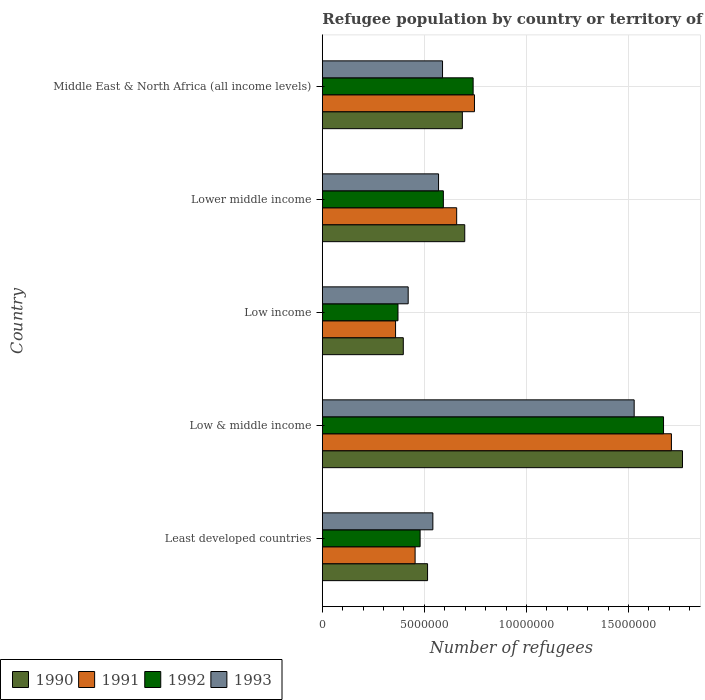How many different coloured bars are there?
Give a very brief answer. 4. Are the number of bars per tick equal to the number of legend labels?
Offer a terse response. Yes. How many bars are there on the 4th tick from the top?
Make the answer very short. 4. How many bars are there on the 3rd tick from the bottom?
Your response must be concise. 4. What is the label of the 1st group of bars from the top?
Give a very brief answer. Middle East & North Africa (all income levels). In how many cases, is the number of bars for a given country not equal to the number of legend labels?
Provide a short and direct response. 0. What is the number of refugees in 1992 in Low & middle income?
Keep it short and to the point. 1.67e+07. Across all countries, what is the maximum number of refugees in 1991?
Ensure brevity in your answer.  1.71e+07. Across all countries, what is the minimum number of refugees in 1993?
Make the answer very short. 4.21e+06. In which country was the number of refugees in 1993 minimum?
Your response must be concise. Low income. What is the total number of refugees in 1991 in the graph?
Your response must be concise. 3.93e+07. What is the difference between the number of refugees in 1990 in Least developed countries and that in Lower middle income?
Give a very brief answer. -1.82e+06. What is the difference between the number of refugees in 1990 in Middle East & North Africa (all income levels) and the number of refugees in 1992 in Low income?
Ensure brevity in your answer.  3.15e+06. What is the average number of refugees in 1993 per country?
Give a very brief answer. 7.30e+06. What is the difference between the number of refugees in 1993 and number of refugees in 1990 in Low & middle income?
Keep it short and to the point. -2.37e+06. In how many countries, is the number of refugees in 1992 greater than 14000000 ?
Your answer should be very brief. 1. What is the ratio of the number of refugees in 1993 in Low & middle income to that in Middle East & North Africa (all income levels)?
Provide a succinct answer. 2.59. Is the number of refugees in 1992 in Low & middle income less than that in Lower middle income?
Provide a short and direct response. No. Is the difference between the number of refugees in 1993 in Least developed countries and Low & middle income greater than the difference between the number of refugees in 1990 in Least developed countries and Low & middle income?
Make the answer very short. Yes. What is the difference between the highest and the second highest number of refugees in 1993?
Offer a terse response. 9.39e+06. What is the difference between the highest and the lowest number of refugees in 1990?
Give a very brief answer. 1.37e+07. In how many countries, is the number of refugees in 1993 greater than the average number of refugees in 1993 taken over all countries?
Your answer should be compact. 1. Is the sum of the number of refugees in 1990 in Low income and Middle East & North Africa (all income levels) greater than the maximum number of refugees in 1993 across all countries?
Make the answer very short. No. Is it the case that in every country, the sum of the number of refugees in 1993 and number of refugees in 1992 is greater than the number of refugees in 1991?
Offer a terse response. Yes. How many countries are there in the graph?
Your answer should be very brief. 5. Does the graph contain grids?
Your answer should be very brief. Yes. Where does the legend appear in the graph?
Make the answer very short. Bottom left. How are the legend labels stacked?
Make the answer very short. Horizontal. What is the title of the graph?
Your answer should be compact. Refugee population by country or territory of asylum. Does "2001" appear as one of the legend labels in the graph?
Provide a short and direct response. No. What is the label or title of the X-axis?
Provide a short and direct response. Number of refugees. What is the label or title of the Y-axis?
Your answer should be compact. Country. What is the Number of refugees in 1990 in Least developed countries?
Offer a very short reply. 5.15e+06. What is the Number of refugees in 1991 in Least developed countries?
Offer a very short reply. 4.54e+06. What is the Number of refugees of 1992 in Least developed countries?
Offer a terse response. 4.79e+06. What is the Number of refugees of 1993 in Least developed countries?
Provide a short and direct response. 5.41e+06. What is the Number of refugees in 1990 in Low & middle income?
Offer a terse response. 1.76e+07. What is the Number of refugees of 1991 in Low & middle income?
Your answer should be very brief. 1.71e+07. What is the Number of refugees in 1992 in Low & middle income?
Provide a succinct answer. 1.67e+07. What is the Number of refugees in 1993 in Low & middle income?
Your answer should be very brief. 1.53e+07. What is the Number of refugees in 1990 in Low income?
Ensure brevity in your answer.  3.97e+06. What is the Number of refugees in 1991 in Low income?
Provide a succinct answer. 3.59e+06. What is the Number of refugees of 1992 in Low income?
Keep it short and to the point. 3.71e+06. What is the Number of refugees of 1993 in Low income?
Give a very brief answer. 4.21e+06. What is the Number of refugees of 1990 in Lower middle income?
Your answer should be compact. 6.98e+06. What is the Number of refugees in 1991 in Lower middle income?
Make the answer very short. 6.58e+06. What is the Number of refugees in 1992 in Lower middle income?
Your answer should be compact. 5.93e+06. What is the Number of refugees in 1993 in Lower middle income?
Keep it short and to the point. 5.69e+06. What is the Number of refugees of 1990 in Middle East & North Africa (all income levels)?
Provide a succinct answer. 6.86e+06. What is the Number of refugees in 1991 in Middle East & North Africa (all income levels)?
Provide a short and direct response. 7.45e+06. What is the Number of refugees in 1992 in Middle East & North Africa (all income levels)?
Keep it short and to the point. 7.39e+06. What is the Number of refugees in 1993 in Middle East & North Africa (all income levels)?
Your answer should be very brief. 5.89e+06. Across all countries, what is the maximum Number of refugees in 1990?
Keep it short and to the point. 1.76e+07. Across all countries, what is the maximum Number of refugees of 1991?
Provide a succinct answer. 1.71e+07. Across all countries, what is the maximum Number of refugees of 1992?
Give a very brief answer. 1.67e+07. Across all countries, what is the maximum Number of refugees in 1993?
Your answer should be very brief. 1.53e+07. Across all countries, what is the minimum Number of refugees of 1990?
Your answer should be very brief. 3.97e+06. Across all countries, what is the minimum Number of refugees in 1991?
Your answer should be compact. 3.59e+06. Across all countries, what is the minimum Number of refugees of 1992?
Provide a short and direct response. 3.71e+06. Across all countries, what is the minimum Number of refugees in 1993?
Provide a short and direct response. 4.21e+06. What is the total Number of refugees in 1990 in the graph?
Your response must be concise. 4.06e+07. What is the total Number of refugees of 1991 in the graph?
Give a very brief answer. 3.93e+07. What is the total Number of refugees in 1992 in the graph?
Offer a very short reply. 3.85e+07. What is the total Number of refugees in 1993 in the graph?
Your answer should be very brief. 3.65e+07. What is the difference between the Number of refugees of 1990 in Least developed countries and that in Low & middle income?
Your response must be concise. -1.25e+07. What is the difference between the Number of refugees in 1991 in Least developed countries and that in Low & middle income?
Provide a succinct answer. -1.26e+07. What is the difference between the Number of refugees in 1992 in Least developed countries and that in Low & middle income?
Offer a terse response. -1.19e+07. What is the difference between the Number of refugees of 1993 in Least developed countries and that in Low & middle income?
Your response must be concise. -9.86e+06. What is the difference between the Number of refugees of 1990 in Least developed countries and that in Low income?
Offer a very short reply. 1.19e+06. What is the difference between the Number of refugees in 1991 in Least developed countries and that in Low income?
Provide a short and direct response. 9.57e+05. What is the difference between the Number of refugees in 1992 in Least developed countries and that in Low income?
Your answer should be compact. 1.08e+06. What is the difference between the Number of refugees of 1993 in Least developed countries and that in Low income?
Give a very brief answer. 1.21e+06. What is the difference between the Number of refugees of 1990 in Least developed countries and that in Lower middle income?
Provide a succinct answer. -1.82e+06. What is the difference between the Number of refugees in 1991 in Least developed countries and that in Lower middle income?
Provide a short and direct response. -2.04e+06. What is the difference between the Number of refugees in 1992 in Least developed countries and that in Lower middle income?
Ensure brevity in your answer.  -1.14e+06. What is the difference between the Number of refugees of 1993 in Least developed countries and that in Lower middle income?
Make the answer very short. -2.78e+05. What is the difference between the Number of refugees of 1990 in Least developed countries and that in Middle East & North Africa (all income levels)?
Your response must be concise. -1.70e+06. What is the difference between the Number of refugees in 1991 in Least developed countries and that in Middle East & North Africa (all income levels)?
Ensure brevity in your answer.  -2.91e+06. What is the difference between the Number of refugees of 1992 in Least developed countries and that in Middle East & North Africa (all income levels)?
Offer a very short reply. -2.60e+06. What is the difference between the Number of refugees of 1993 in Least developed countries and that in Middle East & North Africa (all income levels)?
Offer a terse response. -4.74e+05. What is the difference between the Number of refugees of 1990 in Low & middle income and that in Low income?
Keep it short and to the point. 1.37e+07. What is the difference between the Number of refugees of 1991 in Low & middle income and that in Low income?
Offer a very short reply. 1.35e+07. What is the difference between the Number of refugees in 1992 in Low & middle income and that in Low income?
Provide a short and direct response. 1.30e+07. What is the difference between the Number of refugees of 1993 in Low & middle income and that in Low income?
Offer a very short reply. 1.11e+07. What is the difference between the Number of refugees of 1990 in Low & middle income and that in Lower middle income?
Offer a terse response. 1.07e+07. What is the difference between the Number of refugees of 1991 in Low & middle income and that in Lower middle income?
Your answer should be compact. 1.05e+07. What is the difference between the Number of refugees of 1992 in Low & middle income and that in Lower middle income?
Ensure brevity in your answer.  1.08e+07. What is the difference between the Number of refugees in 1993 in Low & middle income and that in Lower middle income?
Your answer should be compact. 9.58e+06. What is the difference between the Number of refugees in 1990 in Low & middle income and that in Middle East & North Africa (all income levels)?
Your answer should be compact. 1.08e+07. What is the difference between the Number of refugees of 1991 in Low & middle income and that in Middle East & North Africa (all income levels)?
Give a very brief answer. 9.65e+06. What is the difference between the Number of refugees of 1992 in Low & middle income and that in Middle East & North Africa (all income levels)?
Your answer should be compact. 9.33e+06. What is the difference between the Number of refugees of 1993 in Low & middle income and that in Middle East & North Africa (all income levels)?
Your answer should be compact. 9.39e+06. What is the difference between the Number of refugees in 1990 in Low income and that in Lower middle income?
Offer a very short reply. -3.01e+06. What is the difference between the Number of refugees in 1991 in Low income and that in Lower middle income?
Your answer should be very brief. -2.99e+06. What is the difference between the Number of refugees of 1992 in Low income and that in Lower middle income?
Your response must be concise. -2.22e+06. What is the difference between the Number of refugees of 1993 in Low income and that in Lower middle income?
Make the answer very short. -1.49e+06. What is the difference between the Number of refugees of 1990 in Low income and that in Middle East & North Africa (all income levels)?
Your answer should be compact. -2.89e+06. What is the difference between the Number of refugees of 1991 in Low income and that in Middle East & North Africa (all income levels)?
Keep it short and to the point. -3.86e+06. What is the difference between the Number of refugees in 1992 in Low income and that in Middle East & North Africa (all income levels)?
Give a very brief answer. -3.68e+06. What is the difference between the Number of refugees of 1993 in Low income and that in Middle East & North Africa (all income levels)?
Give a very brief answer. -1.68e+06. What is the difference between the Number of refugees in 1990 in Lower middle income and that in Middle East & North Africa (all income levels)?
Provide a succinct answer. 1.17e+05. What is the difference between the Number of refugees in 1991 in Lower middle income and that in Middle East & North Africa (all income levels)?
Ensure brevity in your answer.  -8.71e+05. What is the difference between the Number of refugees of 1992 in Lower middle income and that in Middle East & North Africa (all income levels)?
Offer a very short reply. -1.46e+06. What is the difference between the Number of refugees of 1993 in Lower middle income and that in Middle East & North Africa (all income levels)?
Give a very brief answer. -1.95e+05. What is the difference between the Number of refugees in 1990 in Least developed countries and the Number of refugees in 1991 in Low & middle income?
Offer a very short reply. -1.19e+07. What is the difference between the Number of refugees of 1990 in Least developed countries and the Number of refugees of 1992 in Low & middle income?
Offer a very short reply. -1.16e+07. What is the difference between the Number of refugees in 1990 in Least developed countries and the Number of refugees in 1993 in Low & middle income?
Make the answer very short. -1.01e+07. What is the difference between the Number of refugees in 1991 in Least developed countries and the Number of refugees in 1992 in Low & middle income?
Provide a short and direct response. -1.22e+07. What is the difference between the Number of refugees of 1991 in Least developed countries and the Number of refugees of 1993 in Low & middle income?
Provide a succinct answer. -1.07e+07. What is the difference between the Number of refugees in 1992 in Least developed countries and the Number of refugees in 1993 in Low & middle income?
Offer a terse response. -1.05e+07. What is the difference between the Number of refugees in 1990 in Least developed countries and the Number of refugees in 1991 in Low income?
Offer a terse response. 1.57e+06. What is the difference between the Number of refugees of 1990 in Least developed countries and the Number of refugees of 1992 in Low income?
Give a very brief answer. 1.45e+06. What is the difference between the Number of refugees of 1990 in Least developed countries and the Number of refugees of 1993 in Low income?
Offer a terse response. 9.49e+05. What is the difference between the Number of refugees in 1991 in Least developed countries and the Number of refugees in 1992 in Low income?
Offer a very short reply. 8.38e+05. What is the difference between the Number of refugees of 1991 in Least developed countries and the Number of refugees of 1993 in Low income?
Your response must be concise. 3.39e+05. What is the difference between the Number of refugees of 1992 in Least developed countries and the Number of refugees of 1993 in Low income?
Provide a short and direct response. 5.84e+05. What is the difference between the Number of refugees of 1990 in Least developed countries and the Number of refugees of 1991 in Lower middle income?
Keep it short and to the point. -1.43e+06. What is the difference between the Number of refugees in 1990 in Least developed countries and the Number of refugees in 1992 in Lower middle income?
Your response must be concise. -7.74e+05. What is the difference between the Number of refugees in 1990 in Least developed countries and the Number of refugees in 1993 in Lower middle income?
Provide a succinct answer. -5.38e+05. What is the difference between the Number of refugees in 1991 in Least developed countries and the Number of refugees in 1992 in Lower middle income?
Offer a very short reply. -1.38e+06. What is the difference between the Number of refugees in 1991 in Least developed countries and the Number of refugees in 1993 in Lower middle income?
Make the answer very short. -1.15e+06. What is the difference between the Number of refugees of 1992 in Least developed countries and the Number of refugees of 1993 in Lower middle income?
Keep it short and to the point. -9.03e+05. What is the difference between the Number of refugees of 1990 in Least developed countries and the Number of refugees of 1991 in Middle East & North Africa (all income levels)?
Give a very brief answer. -2.30e+06. What is the difference between the Number of refugees of 1990 in Least developed countries and the Number of refugees of 1992 in Middle East & North Africa (all income levels)?
Ensure brevity in your answer.  -2.23e+06. What is the difference between the Number of refugees in 1990 in Least developed countries and the Number of refugees in 1993 in Middle East & North Africa (all income levels)?
Keep it short and to the point. -7.33e+05. What is the difference between the Number of refugees of 1991 in Least developed countries and the Number of refugees of 1992 in Middle East & North Africa (all income levels)?
Give a very brief answer. -2.84e+06. What is the difference between the Number of refugees of 1991 in Least developed countries and the Number of refugees of 1993 in Middle East & North Africa (all income levels)?
Your answer should be very brief. -1.34e+06. What is the difference between the Number of refugees of 1992 in Least developed countries and the Number of refugees of 1993 in Middle East & North Africa (all income levels)?
Your response must be concise. -1.10e+06. What is the difference between the Number of refugees of 1990 in Low & middle income and the Number of refugees of 1991 in Low income?
Your answer should be compact. 1.41e+07. What is the difference between the Number of refugees in 1990 in Low & middle income and the Number of refugees in 1992 in Low income?
Offer a very short reply. 1.39e+07. What is the difference between the Number of refugees of 1990 in Low & middle income and the Number of refugees of 1993 in Low income?
Provide a succinct answer. 1.34e+07. What is the difference between the Number of refugees of 1991 in Low & middle income and the Number of refugees of 1992 in Low income?
Offer a very short reply. 1.34e+07. What is the difference between the Number of refugees of 1991 in Low & middle income and the Number of refugees of 1993 in Low income?
Give a very brief answer. 1.29e+07. What is the difference between the Number of refugees in 1992 in Low & middle income and the Number of refugees in 1993 in Low income?
Make the answer very short. 1.25e+07. What is the difference between the Number of refugees in 1990 in Low & middle income and the Number of refugees in 1991 in Lower middle income?
Give a very brief answer. 1.11e+07. What is the difference between the Number of refugees in 1990 in Low & middle income and the Number of refugees in 1992 in Lower middle income?
Offer a very short reply. 1.17e+07. What is the difference between the Number of refugees in 1990 in Low & middle income and the Number of refugees in 1993 in Lower middle income?
Offer a terse response. 1.19e+07. What is the difference between the Number of refugees in 1991 in Low & middle income and the Number of refugees in 1992 in Lower middle income?
Your answer should be compact. 1.12e+07. What is the difference between the Number of refugees of 1991 in Low & middle income and the Number of refugees of 1993 in Lower middle income?
Give a very brief answer. 1.14e+07. What is the difference between the Number of refugees in 1992 in Low & middle income and the Number of refugees in 1993 in Lower middle income?
Ensure brevity in your answer.  1.10e+07. What is the difference between the Number of refugees of 1990 in Low & middle income and the Number of refugees of 1991 in Middle East & North Africa (all income levels)?
Provide a short and direct response. 1.02e+07. What is the difference between the Number of refugees of 1990 in Low & middle income and the Number of refugees of 1992 in Middle East & North Africa (all income levels)?
Make the answer very short. 1.03e+07. What is the difference between the Number of refugees in 1990 in Low & middle income and the Number of refugees in 1993 in Middle East & North Africa (all income levels)?
Your answer should be very brief. 1.18e+07. What is the difference between the Number of refugees of 1991 in Low & middle income and the Number of refugees of 1992 in Middle East & North Africa (all income levels)?
Give a very brief answer. 9.71e+06. What is the difference between the Number of refugees of 1991 in Low & middle income and the Number of refugees of 1993 in Middle East & North Africa (all income levels)?
Your answer should be compact. 1.12e+07. What is the difference between the Number of refugees in 1992 in Low & middle income and the Number of refugees in 1993 in Middle East & North Africa (all income levels)?
Provide a succinct answer. 1.08e+07. What is the difference between the Number of refugees in 1990 in Low income and the Number of refugees in 1991 in Lower middle income?
Keep it short and to the point. -2.62e+06. What is the difference between the Number of refugees of 1990 in Low income and the Number of refugees of 1992 in Lower middle income?
Your response must be concise. -1.96e+06. What is the difference between the Number of refugees of 1990 in Low income and the Number of refugees of 1993 in Lower middle income?
Give a very brief answer. -1.73e+06. What is the difference between the Number of refugees of 1991 in Low income and the Number of refugees of 1992 in Lower middle income?
Make the answer very short. -2.34e+06. What is the difference between the Number of refugees in 1991 in Low income and the Number of refugees in 1993 in Lower middle income?
Ensure brevity in your answer.  -2.11e+06. What is the difference between the Number of refugees in 1992 in Low income and the Number of refugees in 1993 in Lower middle income?
Keep it short and to the point. -1.99e+06. What is the difference between the Number of refugees of 1990 in Low income and the Number of refugees of 1991 in Middle East & North Africa (all income levels)?
Offer a terse response. -3.49e+06. What is the difference between the Number of refugees in 1990 in Low income and the Number of refugees in 1992 in Middle East & North Africa (all income levels)?
Give a very brief answer. -3.42e+06. What is the difference between the Number of refugees in 1990 in Low income and the Number of refugees in 1993 in Middle East & North Africa (all income levels)?
Offer a very short reply. -1.92e+06. What is the difference between the Number of refugees in 1991 in Low income and the Number of refugees in 1992 in Middle East & North Africa (all income levels)?
Provide a short and direct response. -3.80e+06. What is the difference between the Number of refugees in 1991 in Low income and the Number of refugees in 1993 in Middle East & North Africa (all income levels)?
Provide a short and direct response. -2.30e+06. What is the difference between the Number of refugees of 1992 in Low income and the Number of refugees of 1993 in Middle East & North Africa (all income levels)?
Provide a succinct answer. -2.18e+06. What is the difference between the Number of refugees in 1990 in Lower middle income and the Number of refugees in 1991 in Middle East & North Africa (all income levels)?
Provide a short and direct response. -4.76e+05. What is the difference between the Number of refugees of 1990 in Lower middle income and the Number of refugees of 1992 in Middle East & North Africa (all income levels)?
Your answer should be compact. -4.11e+05. What is the difference between the Number of refugees in 1990 in Lower middle income and the Number of refugees in 1993 in Middle East & North Africa (all income levels)?
Your response must be concise. 1.09e+06. What is the difference between the Number of refugees of 1991 in Lower middle income and the Number of refugees of 1992 in Middle East & North Africa (all income levels)?
Provide a succinct answer. -8.06e+05. What is the difference between the Number of refugees of 1991 in Lower middle income and the Number of refugees of 1993 in Middle East & North Africa (all income levels)?
Ensure brevity in your answer.  6.93e+05. What is the difference between the Number of refugees of 1992 in Lower middle income and the Number of refugees of 1993 in Middle East & North Africa (all income levels)?
Offer a terse response. 4.07e+04. What is the average Number of refugees in 1990 per country?
Your answer should be very brief. 8.12e+06. What is the average Number of refugees in 1991 per country?
Give a very brief answer. 7.85e+06. What is the average Number of refugees of 1992 per country?
Ensure brevity in your answer.  7.70e+06. What is the average Number of refugees of 1993 per country?
Your answer should be very brief. 7.30e+06. What is the difference between the Number of refugees in 1990 and Number of refugees in 1991 in Least developed countries?
Your response must be concise. 6.10e+05. What is the difference between the Number of refugees of 1990 and Number of refugees of 1992 in Least developed countries?
Offer a very short reply. 3.65e+05. What is the difference between the Number of refugees of 1990 and Number of refugees of 1993 in Least developed countries?
Make the answer very short. -2.60e+05. What is the difference between the Number of refugees of 1991 and Number of refugees of 1992 in Least developed countries?
Offer a very short reply. -2.45e+05. What is the difference between the Number of refugees in 1991 and Number of refugees in 1993 in Least developed countries?
Make the answer very short. -8.70e+05. What is the difference between the Number of refugees of 1992 and Number of refugees of 1993 in Least developed countries?
Make the answer very short. -6.25e+05. What is the difference between the Number of refugees in 1990 and Number of refugees in 1991 in Low & middle income?
Provide a succinct answer. 5.42e+05. What is the difference between the Number of refugees in 1990 and Number of refugees in 1992 in Low & middle income?
Your answer should be compact. 9.28e+05. What is the difference between the Number of refugees of 1990 and Number of refugees of 1993 in Low & middle income?
Offer a very short reply. 2.37e+06. What is the difference between the Number of refugees in 1991 and Number of refugees in 1992 in Low & middle income?
Ensure brevity in your answer.  3.87e+05. What is the difference between the Number of refugees in 1991 and Number of refugees in 1993 in Low & middle income?
Make the answer very short. 1.82e+06. What is the difference between the Number of refugees in 1992 and Number of refugees in 1993 in Low & middle income?
Offer a very short reply. 1.44e+06. What is the difference between the Number of refugees of 1990 and Number of refugees of 1991 in Low income?
Offer a very short reply. 3.78e+05. What is the difference between the Number of refugees in 1990 and Number of refugees in 1992 in Low income?
Your answer should be compact. 2.60e+05. What is the difference between the Number of refugees of 1990 and Number of refugees of 1993 in Low income?
Keep it short and to the point. -2.40e+05. What is the difference between the Number of refugees in 1991 and Number of refugees in 1992 in Low income?
Ensure brevity in your answer.  -1.19e+05. What is the difference between the Number of refugees in 1991 and Number of refugees in 1993 in Low income?
Provide a succinct answer. -6.18e+05. What is the difference between the Number of refugees in 1992 and Number of refugees in 1993 in Low income?
Ensure brevity in your answer.  -5.00e+05. What is the difference between the Number of refugees of 1990 and Number of refugees of 1991 in Lower middle income?
Ensure brevity in your answer.  3.95e+05. What is the difference between the Number of refugees of 1990 and Number of refugees of 1992 in Lower middle income?
Your response must be concise. 1.05e+06. What is the difference between the Number of refugees in 1990 and Number of refugees in 1993 in Lower middle income?
Provide a short and direct response. 1.28e+06. What is the difference between the Number of refugees in 1991 and Number of refugees in 1992 in Lower middle income?
Provide a short and direct response. 6.52e+05. What is the difference between the Number of refugees in 1991 and Number of refugees in 1993 in Lower middle income?
Provide a succinct answer. 8.88e+05. What is the difference between the Number of refugees of 1992 and Number of refugees of 1993 in Lower middle income?
Keep it short and to the point. 2.36e+05. What is the difference between the Number of refugees of 1990 and Number of refugees of 1991 in Middle East & North Africa (all income levels)?
Your response must be concise. -5.93e+05. What is the difference between the Number of refugees of 1990 and Number of refugees of 1992 in Middle East & North Africa (all income levels)?
Your answer should be very brief. -5.28e+05. What is the difference between the Number of refugees of 1990 and Number of refugees of 1993 in Middle East & North Africa (all income levels)?
Provide a short and direct response. 9.71e+05. What is the difference between the Number of refugees in 1991 and Number of refugees in 1992 in Middle East & North Africa (all income levels)?
Offer a very short reply. 6.48e+04. What is the difference between the Number of refugees in 1991 and Number of refugees in 1993 in Middle East & North Africa (all income levels)?
Your answer should be compact. 1.56e+06. What is the difference between the Number of refugees of 1992 and Number of refugees of 1993 in Middle East & North Africa (all income levels)?
Ensure brevity in your answer.  1.50e+06. What is the ratio of the Number of refugees of 1990 in Least developed countries to that in Low & middle income?
Keep it short and to the point. 0.29. What is the ratio of the Number of refugees of 1991 in Least developed countries to that in Low & middle income?
Offer a very short reply. 0.27. What is the ratio of the Number of refugees of 1992 in Least developed countries to that in Low & middle income?
Your response must be concise. 0.29. What is the ratio of the Number of refugees in 1993 in Least developed countries to that in Low & middle income?
Provide a short and direct response. 0.35. What is the ratio of the Number of refugees of 1990 in Least developed countries to that in Low income?
Your response must be concise. 1.3. What is the ratio of the Number of refugees in 1991 in Least developed countries to that in Low income?
Give a very brief answer. 1.27. What is the ratio of the Number of refugees in 1992 in Least developed countries to that in Low income?
Your response must be concise. 1.29. What is the ratio of the Number of refugees in 1993 in Least developed countries to that in Low income?
Your answer should be very brief. 1.29. What is the ratio of the Number of refugees of 1990 in Least developed countries to that in Lower middle income?
Offer a very short reply. 0.74. What is the ratio of the Number of refugees in 1991 in Least developed countries to that in Lower middle income?
Offer a terse response. 0.69. What is the ratio of the Number of refugees in 1992 in Least developed countries to that in Lower middle income?
Make the answer very short. 0.81. What is the ratio of the Number of refugees in 1993 in Least developed countries to that in Lower middle income?
Your response must be concise. 0.95. What is the ratio of the Number of refugees in 1990 in Least developed countries to that in Middle East & North Africa (all income levels)?
Provide a short and direct response. 0.75. What is the ratio of the Number of refugees of 1991 in Least developed countries to that in Middle East & North Africa (all income levels)?
Your answer should be very brief. 0.61. What is the ratio of the Number of refugees in 1992 in Least developed countries to that in Middle East & North Africa (all income levels)?
Your answer should be very brief. 0.65. What is the ratio of the Number of refugees in 1993 in Least developed countries to that in Middle East & North Africa (all income levels)?
Your answer should be very brief. 0.92. What is the ratio of the Number of refugees in 1990 in Low & middle income to that in Low income?
Offer a very short reply. 4.45. What is the ratio of the Number of refugees in 1991 in Low & middle income to that in Low income?
Your response must be concise. 4.77. What is the ratio of the Number of refugees of 1992 in Low & middle income to that in Low income?
Your response must be concise. 4.51. What is the ratio of the Number of refugees of 1993 in Low & middle income to that in Low income?
Your answer should be very brief. 3.63. What is the ratio of the Number of refugees in 1990 in Low & middle income to that in Lower middle income?
Your answer should be compact. 2.53. What is the ratio of the Number of refugees of 1991 in Low & middle income to that in Lower middle income?
Give a very brief answer. 2.6. What is the ratio of the Number of refugees in 1992 in Low & middle income to that in Lower middle income?
Give a very brief answer. 2.82. What is the ratio of the Number of refugees in 1993 in Low & middle income to that in Lower middle income?
Offer a terse response. 2.68. What is the ratio of the Number of refugees of 1990 in Low & middle income to that in Middle East & North Africa (all income levels)?
Your answer should be very brief. 2.57. What is the ratio of the Number of refugees in 1991 in Low & middle income to that in Middle East & North Africa (all income levels)?
Your answer should be compact. 2.29. What is the ratio of the Number of refugees of 1992 in Low & middle income to that in Middle East & North Africa (all income levels)?
Your answer should be very brief. 2.26. What is the ratio of the Number of refugees of 1993 in Low & middle income to that in Middle East & North Africa (all income levels)?
Your answer should be very brief. 2.59. What is the ratio of the Number of refugees in 1990 in Low income to that in Lower middle income?
Keep it short and to the point. 0.57. What is the ratio of the Number of refugees of 1991 in Low income to that in Lower middle income?
Provide a succinct answer. 0.55. What is the ratio of the Number of refugees of 1992 in Low income to that in Lower middle income?
Ensure brevity in your answer.  0.63. What is the ratio of the Number of refugees in 1993 in Low income to that in Lower middle income?
Offer a very short reply. 0.74. What is the ratio of the Number of refugees of 1990 in Low income to that in Middle East & North Africa (all income levels)?
Ensure brevity in your answer.  0.58. What is the ratio of the Number of refugees in 1991 in Low income to that in Middle East & North Africa (all income levels)?
Offer a very short reply. 0.48. What is the ratio of the Number of refugees in 1992 in Low income to that in Middle East & North Africa (all income levels)?
Your answer should be compact. 0.5. What is the ratio of the Number of refugees of 1990 in Lower middle income to that in Middle East & North Africa (all income levels)?
Give a very brief answer. 1.02. What is the ratio of the Number of refugees in 1991 in Lower middle income to that in Middle East & North Africa (all income levels)?
Provide a succinct answer. 0.88. What is the ratio of the Number of refugees of 1992 in Lower middle income to that in Middle East & North Africa (all income levels)?
Provide a short and direct response. 0.8. What is the ratio of the Number of refugees of 1993 in Lower middle income to that in Middle East & North Africa (all income levels)?
Provide a short and direct response. 0.97. What is the difference between the highest and the second highest Number of refugees of 1990?
Your response must be concise. 1.07e+07. What is the difference between the highest and the second highest Number of refugees of 1991?
Keep it short and to the point. 9.65e+06. What is the difference between the highest and the second highest Number of refugees of 1992?
Give a very brief answer. 9.33e+06. What is the difference between the highest and the second highest Number of refugees in 1993?
Your answer should be very brief. 9.39e+06. What is the difference between the highest and the lowest Number of refugees in 1990?
Make the answer very short. 1.37e+07. What is the difference between the highest and the lowest Number of refugees of 1991?
Your response must be concise. 1.35e+07. What is the difference between the highest and the lowest Number of refugees of 1992?
Ensure brevity in your answer.  1.30e+07. What is the difference between the highest and the lowest Number of refugees in 1993?
Keep it short and to the point. 1.11e+07. 